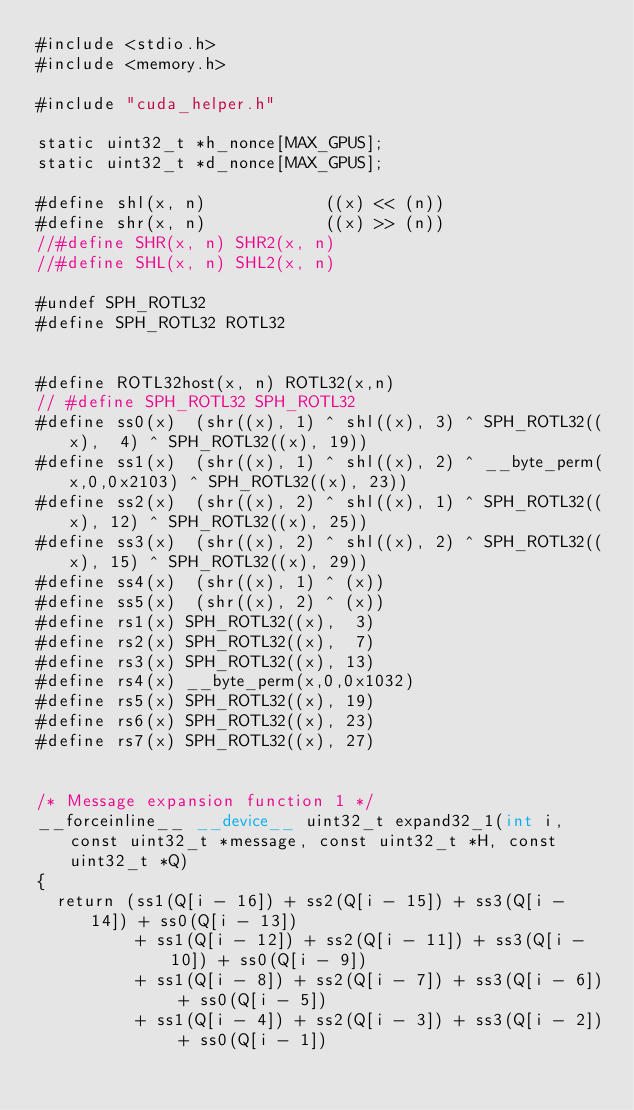Convert code to text. <code><loc_0><loc_0><loc_500><loc_500><_Cuda_>#include <stdio.h>
#include <memory.h>

#include "cuda_helper.h"

static uint32_t *h_nonce[MAX_GPUS];
static uint32_t *d_nonce[MAX_GPUS];

#define shl(x, n)            ((x) << (n))
#define shr(x, n)            ((x) >> (n))
//#define SHR(x, n) SHR2(x, n) 
//#define SHL(x, n) SHL2(x, n) 

#undef SPH_ROTL32
#define SPH_ROTL32 ROTL32


#define ROTL32host(x, n) ROTL32(x,n)
// #define SPH_ROTL32 SPH_ROTL32
#define ss0(x)  (shr((x), 1) ^ shl((x), 3) ^ SPH_ROTL32((x),  4) ^ SPH_ROTL32((x), 19))
#define ss1(x)  (shr((x), 1) ^ shl((x), 2) ^ __byte_perm(x,0,0x2103) ^ SPH_ROTL32((x), 23))
#define ss2(x)  (shr((x), 2) ^ shl((x), 1) ^ SPH_ROTL32((x), 12) ^ SPH_ROTL32((x), 25))
#define ss3(x)  (shr((x), 2) ^ shl((x), 2) ^ SPH_ROTL32((x), 15) ^ SPH_ROTL32((x), 29))
#define ss4(x)  (shr((x), 1) ^ (x))
#define ss5(x)  (shr((x), 2) ^ (x))
#define rs1(x) SPH_ROTL32((x),  3)
#define rs2(x) SPH_ROTL32((x),  7)
#define rs3(x) SPH_ROTL32((x), 13)
#define rs4(x) __byte_perm(x,0,0x1032)
#define rs5(x) SPH_ROTL32((x), 19)
#define rs6(x) SPH_ROTL32((x), 23)
#define rs7(x) SPH_ROTL32((x), 27)


/* Message expansion function 1 */
__forceinline__ __device__ uint32_t expand32_1(int i, const uint32_t *message, const uint32_t *H, const uint32_t *Q)
{
	return (ss1(Q[i - 16]) + ss2(Q[i - 15]) + ss3(Q[i - 14]) + ss0(Q[i - 13])
					+ ss1(Q[i - 12]) + ss2(Q[i - 11]) + ss3(Q[i - 10]) + ss0(Q[i - 9])
					+ ss1(Q[i - 8]) + ss2(Q[i - 7]) + ss3(Q[i - 6]) + ss0(Q[i - 5])
					+ ss1(Q[i - 4]) + ss2(Q[i - 3]) + ss3(Q[i - 2]) + ss0(Q[i - 1])</code> 